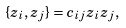<formula> <loc_0><loc_0><loc_500><loc_500>\{ z _ { i } , z _ { j } \} = c _ { i j } z _ { i } z _ { j } ,</formula> 